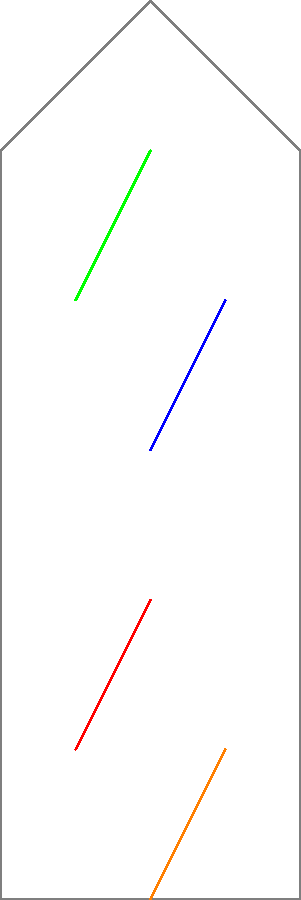In your medical oddities museum, you're assembling a historical skeleton display. Four fragmented bones (A, B, C, and D) need to be matched correctly to complete the skeleton. Based on the diagram, which two bones should be connected to form the left side of the skeleton? To solve this spatial intelligence problem, let's analyze the diagram step-by-step:

1. We see a skeleton outline in gray, with four colored bone fragments labeled A, B, C, and D.

2. The skeleton has a symmetrical structure, suggesting we need to form two long bones on each side.

3. The dashed lines indicate the correct connections between the fragments.

4. Observing the left side of the skeleton:
   - Bone A (red) is at the bottom left
   - Bone B (blue) is at the top left

5. The dashed line connects Bone A and Bone B, indicating they should be joined to form the left side of the skeleton.

6. For completeness, we can see that Bones C and D would form the right side, but this is not asked in the question.

Therefore, the correct match for the left side of the skeleton is Bone A connected to Bone B.
Answer: A and B 